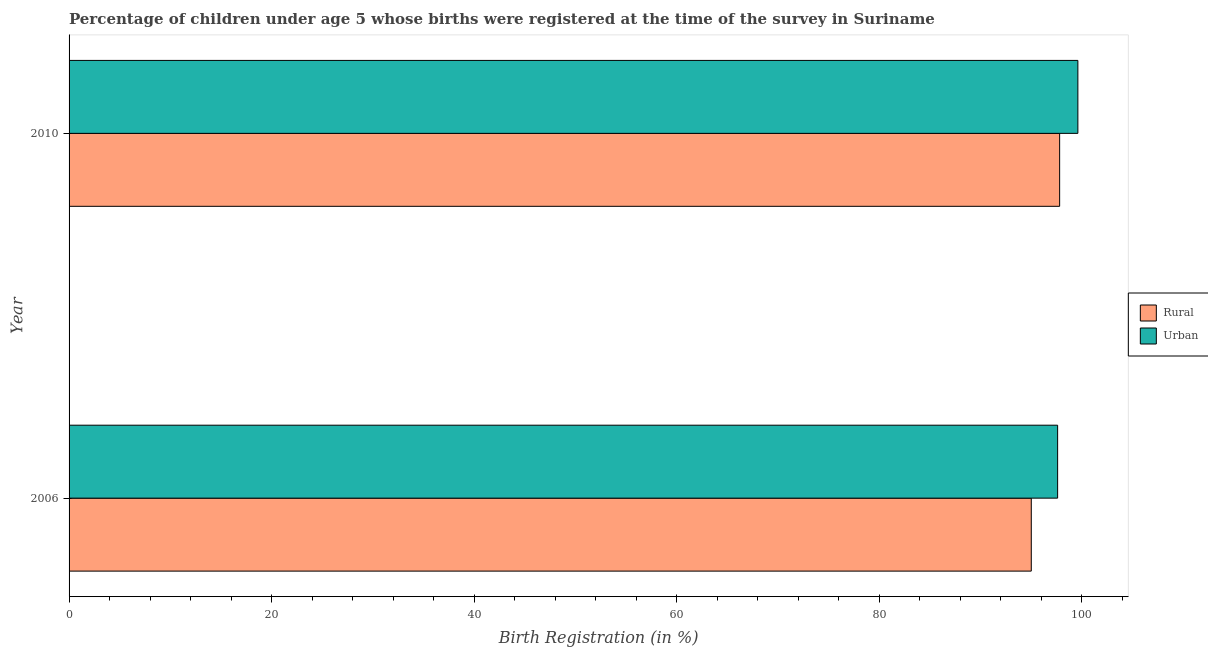What is the label of the 1st group of bars from the top?
Provide a short and direct response. 2010. Across all years, what is the maximum rural birth registration?
Your answer should be compact. 97.8. Across all years, what is the minimum urban birth registration?
Keep it short and to the point. 97.6. In which year was the rural birth registration maximum?
Offer a terse response. 2010. In which year was the rural birth registration minimum?
Your response must be concise. 2006. What is the total urban birth registration in the graph?
Provide a short and direct response. 197.2. What is the difference between the urban birth registration in 2006 and that in 2010?
Make the answer very short. -2. What is the difference between the urban birth registration in 2006 and the rural birth registration in 2010?
Your response must be concise. -0.2. What is the average urban birth registration per year?
Provide a succinct answer. 98.6. In how many years, is the rural birth registration greater than 8 %?
Provide a short and direct response. 2. Is the difference between the urban birth registration in 2006 and 2010 greater than the difference between the rural birth registration in 2006 and 2010?
Your answer should be very brief. Yes. In how many years, is the urban birth registration greater than the average urban birth registration taken over all years?
Keep it short and to the point. 1. What does the 2nd bar from the top in 2010 represents?
Give a very brief answer. Rural. What does the 2nd bar from the bottom in 2010 represents?
Your response must be concise. Urban. How many bars are there?
Ensure brevity in your answer.  4. Are all the bars in the graph horizontal?
Provide a short and direct response. Yes. What is the difference between two consecutive major ticks on the X-axis?
Provide a short and direct response. 20. Does the graph contain any zero values?
Offer a very short reply. No. Where does the legend appear in the graph?
Offer a very short reply. Center right. How many legend labels are there?
Provide a succinct answer. 2. What is the title of the graph?
Offer a terse response. Percentage of children under age 5 whose births were registered at the time of the survey in Suriname. What is the label or title of the X-axis?
Offer a terse response. Birth Registration (in %). What is the Birth Registration (in %) of Urban in 2006?
Your response must be concise. 97.6. What is the Birth Registration (in %) of Rural in 2010?
Offer a terse response. 97.8. What is the Birth Registration (in %) in Urban in 2010?
Offer a very short reply. 99.6. Across all years, what is the maximum Birth Registration (in %) of Rural?
Make the answer very short. 97.8. Across all years, what is the maximum Birth Registration (in %) in Urban?
Make the answer very short. 99.6. Across all years, what is the minimum Birth Registration (in %) in Rural?
Ensure brevity in your answer.  95. Across all years, what is the minimum Birth Registration (in %) in Urban?
Your response must be concise. 97.6. What is the total Birth Registration (in %) in Rural in the graph?
Offer a very short reply. 192.8. What is the total Birth Registration (in %) in Urban in the graph?
Provide a short and direct response. 197.2. What is the difference between the Birth Registration (in %) in Rural in 2006 and that in 2010?
Make the answer very short. -2.8. What is the difference between the Birth Registration (in %) of Rural in 2006 and the Birth Registration (in %) of Urban in 2010?
Ensure brevity in your answer.  -4.6. What is the average Birth Registration (in %) of Rural per year?
Provide a succinct answer. 96.4. What is the average Birth Registration (in %) in Urban per year?
Offer a terse response. 98.6. What is the ratio of the Birth Registration (in %) of Rural in 2006 to that in 2010?
Provide a short and direct response. 0.97. What is the ratio of the Birth Registration (in %) of Urban in 2006 to that in 2010?
Keep it short and to the point. 0.98. What is the difference between the highest and the second highest Birth Registration (in %) in Urban?
Your answer should be compact. 2. What is the difference between the highest and the lowest Birth Registration (in %) in Rural?
Offer a terse response. 2.8. 